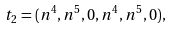Convert formula to latex. <formula><loc_0><loc_0><loc_500><loc_500>t _ { 2 } = ( n ^ { 4 } , n ^ { 5 } , 0 , n ^ { 4 } , n ^ { 5 } , 0 ) ,</formula> 